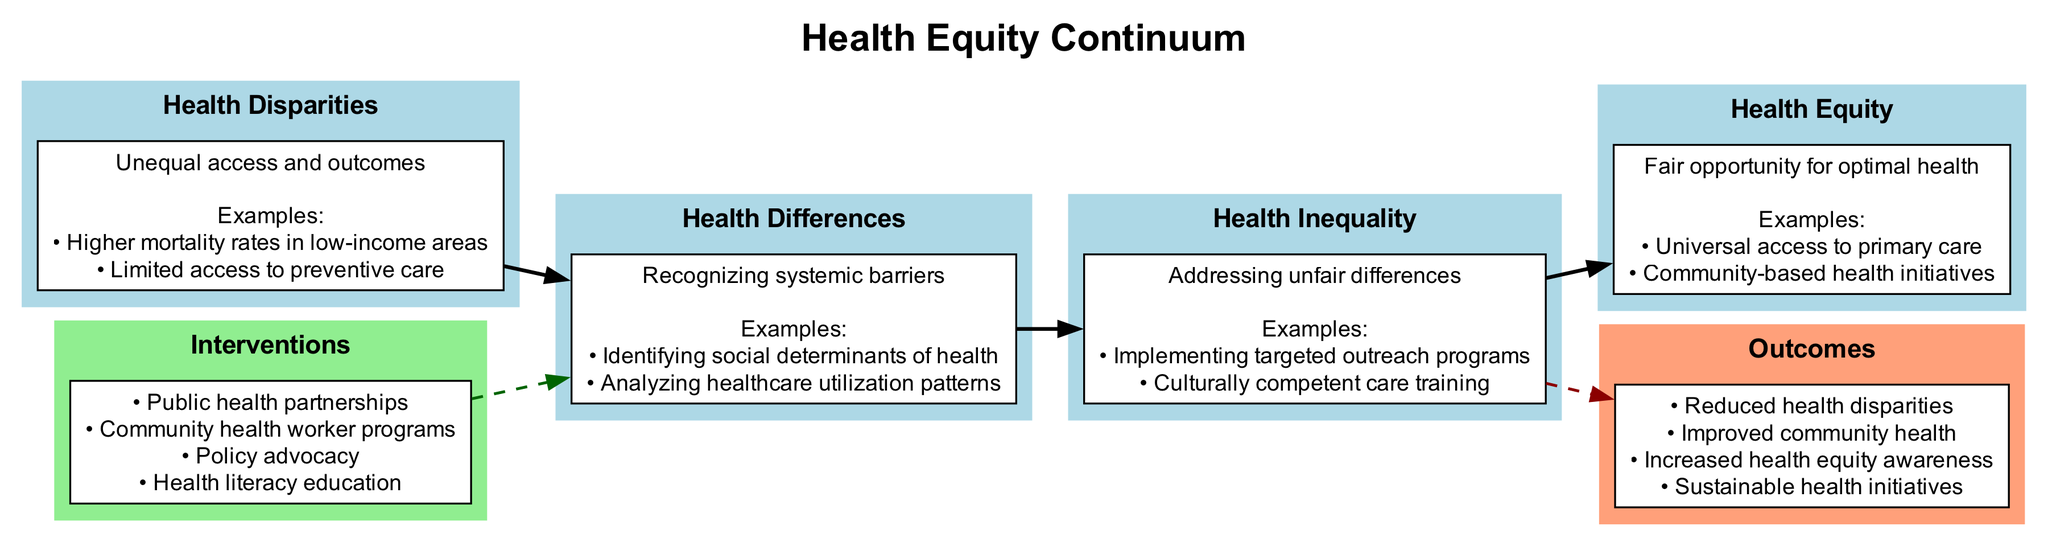What are the four stages in the health equity continuum? The diagram lists four distinct stages: Health Disparities, Health Differences, Health Inequality, and Health Equity. These stages are connected in a linear progression from disparities to equity in healthcare.
Answer: Health Disparities, Health Differences, Health Inequality, Health Equity What intervention is mentioned in the diagram? The diagram includes interventions that address health equity, such as Public health partnerships, Community health worker programs, Policy advocacy, and Health literacy education. Each of these interventions aims to facilitate progression towards health equity.
Answer: Public health partnerships, Community health worker programs, Policy advocacy, Health literacy education How many examples are provided under the stage "Health Inequality"? In the stage "Health Inequality", there are two examples listed: Implementing targeted outreach programs and Culturally competent care training. The diagram presents these examples to illustrate actions taken to address unfair differences.
Answer: 2 What type of care is emphasized under Health Equity? The stage of Health Equity emphasizes Universal access to primary care, highlighting the goal of providing all individuals with equal access to essential health services. This point illustrates a significant outcome of progressing through the health equity continuum.
Answer: Universal access to primary care What connects the "Interventions" cluster to the continuum of health equity? The connection between the "Interventions" cluster and the continuum is illustrated by a dashed line that points to the first stage, "Health Differences." This indicates that interventions are aimed at influencing health differences and barriers to achieving equity.
Answer: A dashed line What is the expected outcome of reaching "Health Equity"? One of the expected outcomes of reaching Health Equity is Improved community health. This outcome signifies the overall effectiveness of efforts made to eliminate disparities and create equitable health opportunities.
Answer: Improved community health What stage acknowledges systemic barriers? The stage that acknowledges systemic barriers is Health Differences. This stage focuses on recognizing and understanding the structural factors that contribute to health disparities.
Answer: Health Differences How many stages are connected in the diagram? The diagram shows a total of four stages connected in a linear fashion, indicating a sequential process towards achieving health equity. Each stage builds upon the previous one to create a comprehensive understanding of health equity progression.
Answer: 4 